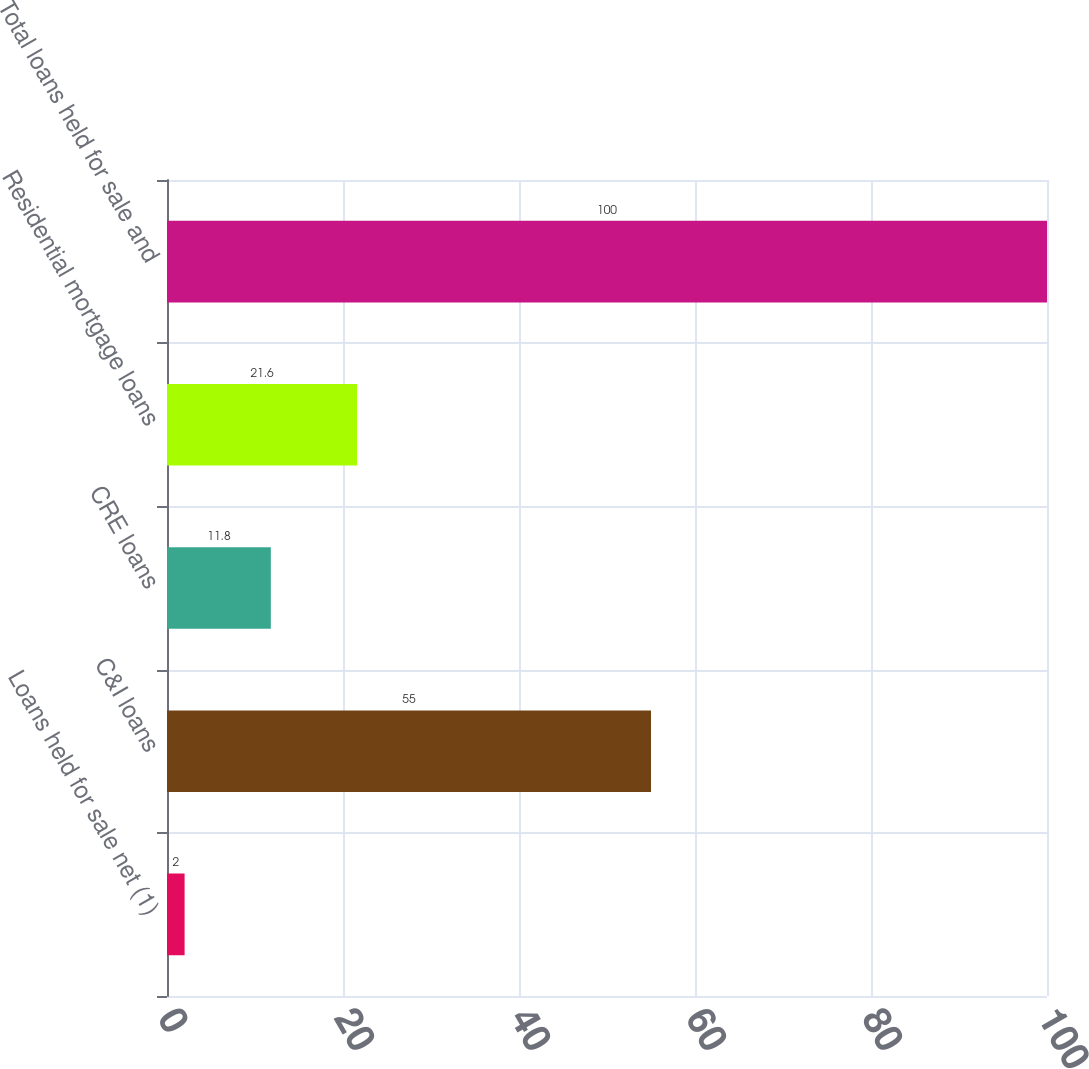<chart> <loc_0><loc_0><loc_500><loc_500><bar_chart><fcel>Loans held for sale net (1)<fcel>C&I loans<fcel>CRE loans<fcel>Residential mortgage loans<fcel>Total loans held for sale and<nl><fcel>2<fcel>55<fcel>11.8<fcel>21.6<fcel>100<nl></chart> 